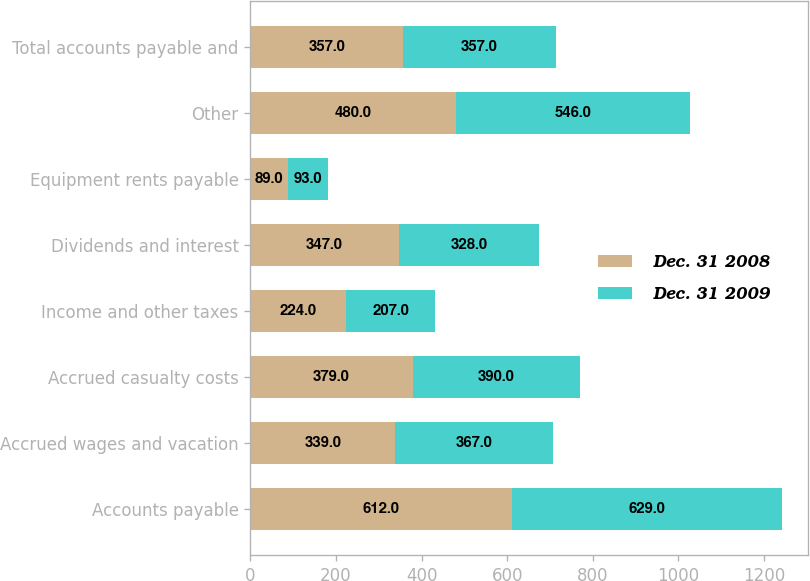<chart> <loc_0><loc_0><loc_500><loc_500><stacked_bar_chart><ecel><fcel>Accounts payable<fcel>Accrued wages and vacation<fcel>Accrued casualty costs<fcel>Income and other taxes<fcel>Dividends and interest<fcel>Equipment rents payable<fcel>Other<fcel>Total accounts payable and<nl><fcel>Dec. 31 2008<fcel>612<fcel>339<fcel>379<fcel>224<fcel>347<fcel>89<fcel>480<fcel>357<nl><fcel>Dec. 31 2009<fcel>629<fcel>367<fcel>390<fcel>207<fcel>328<fcel>93<fcel>546<fcel>357<nl></chart> 